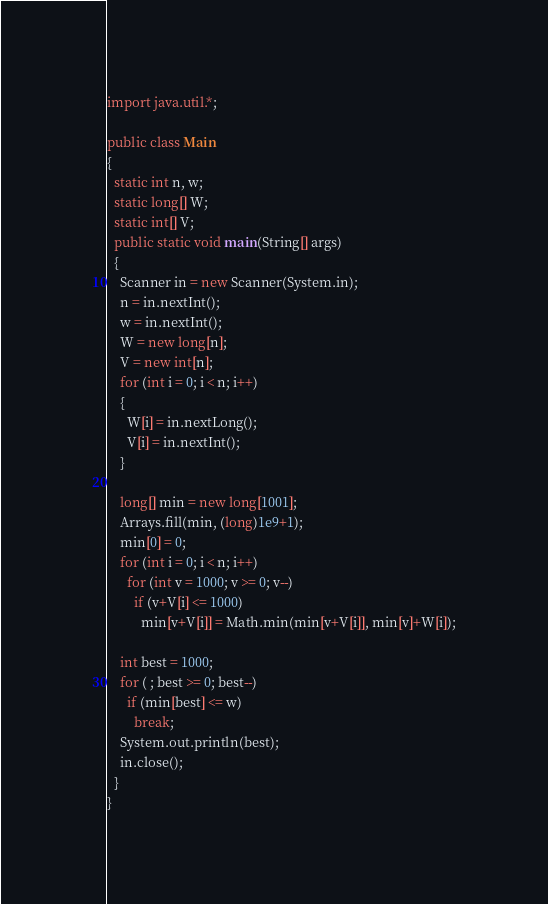<code> <loc_0><loc_0><loc_500><loc_500><_Java_>import java.util.*;

public class Main
{
  static int n, w;
  static long[] W;
  static int[] V;
  public static void main(String[] args)
  {
	Scanner in = new Scanner(System.in);
    n = in.nextInt();
    w = in.nextInt();
    W = new long[n];
    V = new int[n];
    for (int i = 0; i < n; i++)
    {
      W[i] = in.nextLong();
      V[i] = in.nextInt();
    }
    
    long[] min = new long[1001];
    Arrays.fill(min, (long)1e9+1);
    min[0] = 0;
    for (int i = 0; i < n; i++)
      for (int v = 1000; v >= 0; v--)
        if (v+V[i] <= 1000)
          min[v+V[i]] = Math.min(min[v+V[i]], min[v]+W[i]);
    
    int best = 1000;
    for ( ; best >= 0; best--)
      if (min[best] <= w)
        break;
    System.out.println(best);        
    in.close();
  }
}
</code> 